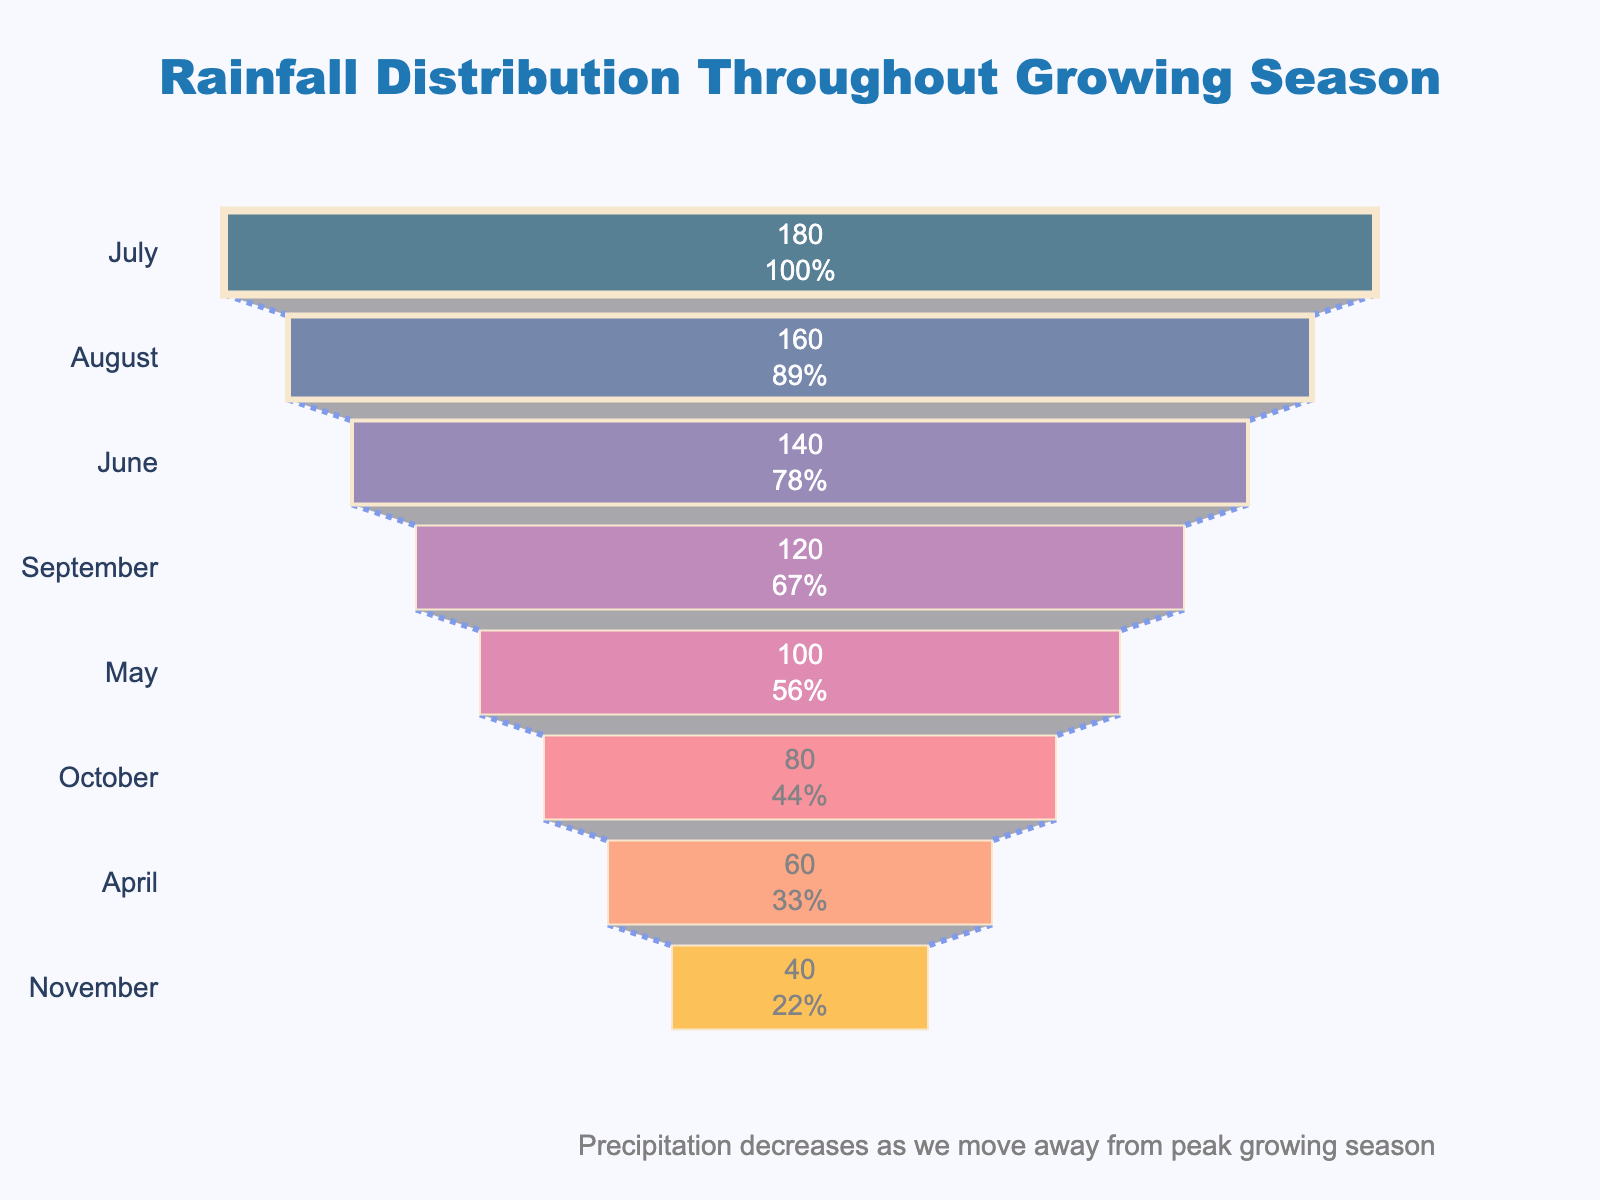What's the month with the highest precipitation? July has the highest precipitation value on top of the funnel chart, which is the widest section representing the most rainfall.
Answer: July What's the month with the lowest precipitation? November is at the bottom of the funnel chart and has the smallest width, representing the least rainfall.
Answer: November How much precipitation is recorded in August? The section labeled "August" shows a precipitation value of 160 mm inside the funnel chart.
Answer: 160 mm What is the title of the chart? The title is shown at the top of the chart in bold letters. It reads "Rainfall Distribution Throughout Growing Season."
Answer: Rainfall Distribution Throughout Growing Season Which months together contribute to more than 50% of the total rainfall? July and August combined cover more than 50% of the total rainfall as their cumulative percentage in the funnel chart exceeds 50%.
Answer: July and August How much higher is the precipitation in June compared to May? The precipitation in June is 140 mm, and in May, it is 100 mm. The difference is 140 mm - 100 mm = 40 mm.
Answer: 40 mm What is the average precipitation between April and September? Precipitation values for April, May, June, July, August, and September are 60 mm, 100 mm, 140 mm, 180 mm, 160 mm, and 120 mm. Sum = 60 + 100 + 140 + 180 + 160 + 120 = 760 mm. Average = 760 mm / 6 = 126.67 mm.
Answer: 126.67 mm How is the change in precipitation represented in the chart? Changes in precipitation are represented by the decreasing width of the funnel chart sections from top to bottom.
Answer: Decreasing width of sections Which month has precipitation closest to 100 mm? May shows a precipitation value closest to 100 mm as labeled inside the funnel.
Answer: May By what percentage does the precipitation reduce from July to October? July's precipitation is 180 mm, and October's is 80 mm. The reduction in mm = 180 - 80 = 100 mm. Percentage reduction = (100 / 180) × 100% = 55.56%.
Answer: 55.56% 